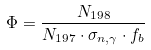<formula> <loc_0><loc_0><loc_500><loc_500>\Phi = \frac { N _ { 1 9 8 } } { N _ { 1 9 7 } \cdot \sigma _ { n , \gamma } \cdot f _ { b } }</formula> 